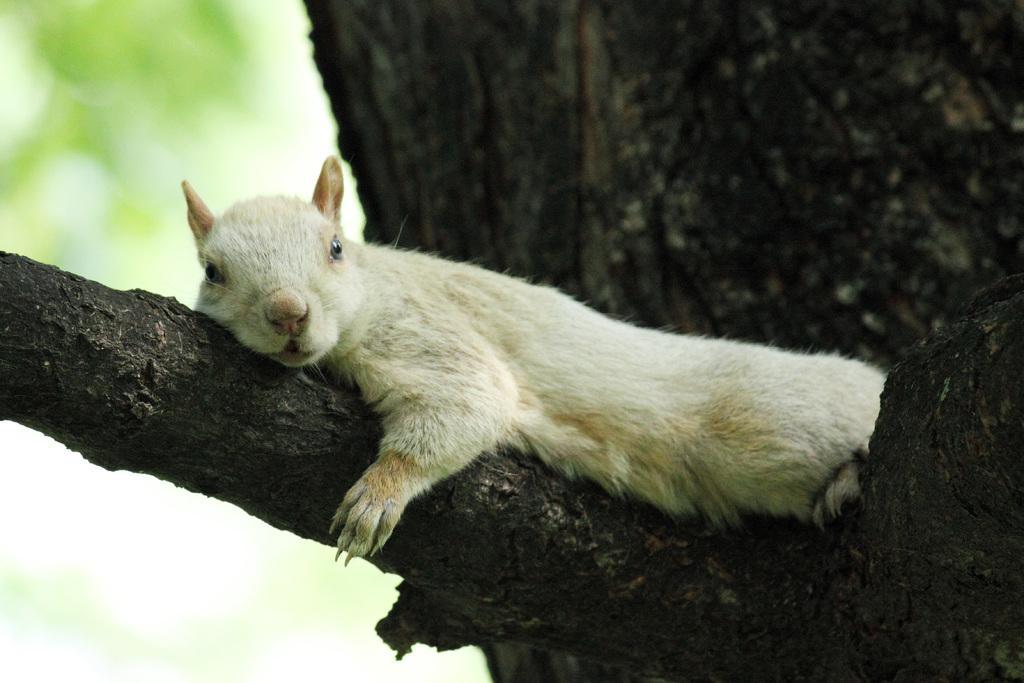Describe this image in one or two sentences. In the image there is an animal lying on the branch of a tree and the background of the animal is blur. 